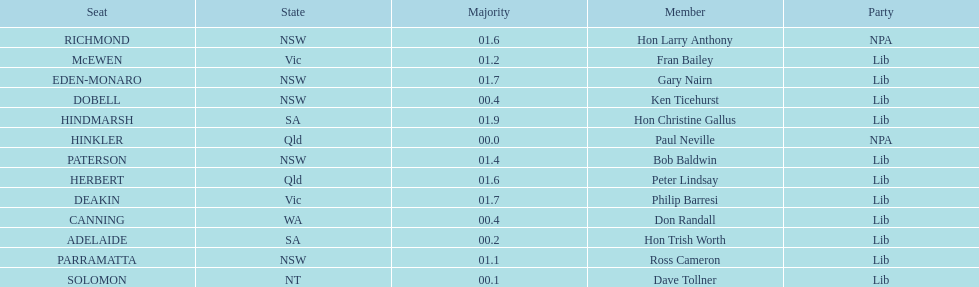How many states were included in the seats? 6. 